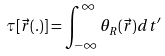<formula> <loc_0><loc_0><loc_500><loc_500>\tau [ \vec { r } ( . ) ] = \int _ { - \infty } ^ { \infty } \theta _ { R } ( \vec { r } ) d t ^ { \prime }</formula> 